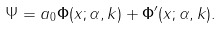Convert formula to latex. <formula><loc_0><loc_0><loc_500><loc_500>\Psi = a _ { 0 } \mathbf \Phi ( x ; \alpha , k ) + \mathbf \Phi ^ { \prime } ( x ; \alpha , k ) .</formula> 